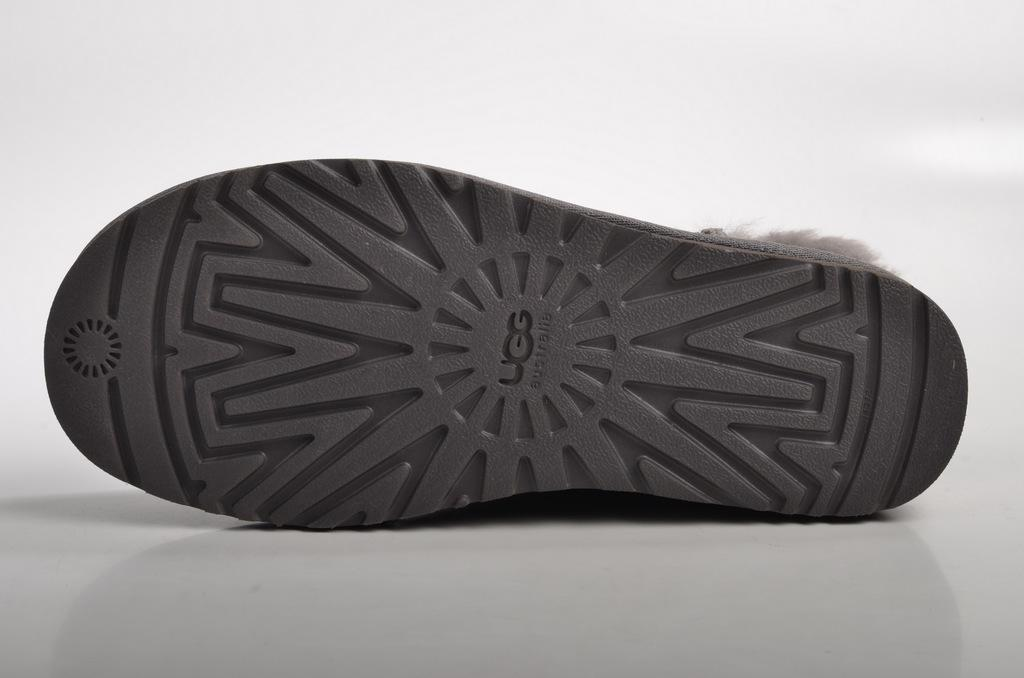What is the main object in the image that has a black color? There is a black color thing in the image. What is on the black color thing? There is writing on the black color thing. What is the color of the surface where the writing is present? The writing is on a white color surface. What can be seen in the background of the image? The background of the image is white. Is there a prison visible in the image? No, there is no prison present in the image. Can you see someone trying to balance something in the image? No, there is no indication of someone trying to balance anything in the image. 